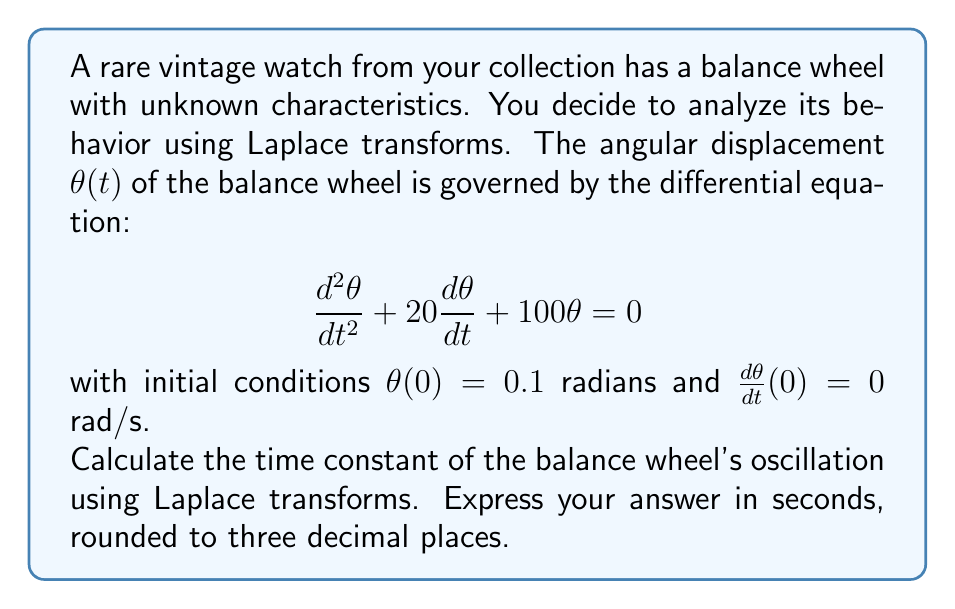Could you help me with this problem? Let's approach this step-by-step using Laplace transforms:

1) First, we take the Laplace transform of the differential equation:
   $$\mathcal{L}\left\{\frac{d^2\theta}{dt^2} + 20\frac{d\theta}{dt} + 100\theta\right\} = \mathcal{L}\{0\}$$

2) Using Laplace transform properties:
   $$s^2\Theta(s) - s\theta(0) - \theta'(0) + 20[s\Theta(s) - \theta(0)] + 100\Theta(s) = 0$$

3) Substituting the initial conditions:
   $$s^2\Theta(s) - 0.1s + 20s\Theta(s) - 2 + 100\Theta(s) = 0$$

4) Rearranging:
   $$(s^2 + 20s + 100)\Theta(s) = 0.1s + 2$$

5) Solving for $\Theta(s)$:
   $$\Theta(s) = \frac{0.1s + 2}{s^2 + 20s + 100}$$

6) The denominator can be factored as:
   $$s^2 + 20s + 100 = (s + 10)^2 + 0$$

7) This corresponds to a critically damped system with a repeated root at $s = -10$.

8) The time constant $\tau$ is the negative reciprocal of this root:
   $$\tau = -\frac{1}{-10} = 0.1\text{ seconds}$$

The time constant represents the time it takes for the system's response to decay to about 36.8% (1/e) of its initial value.
Answer: $0.100$ seconds 